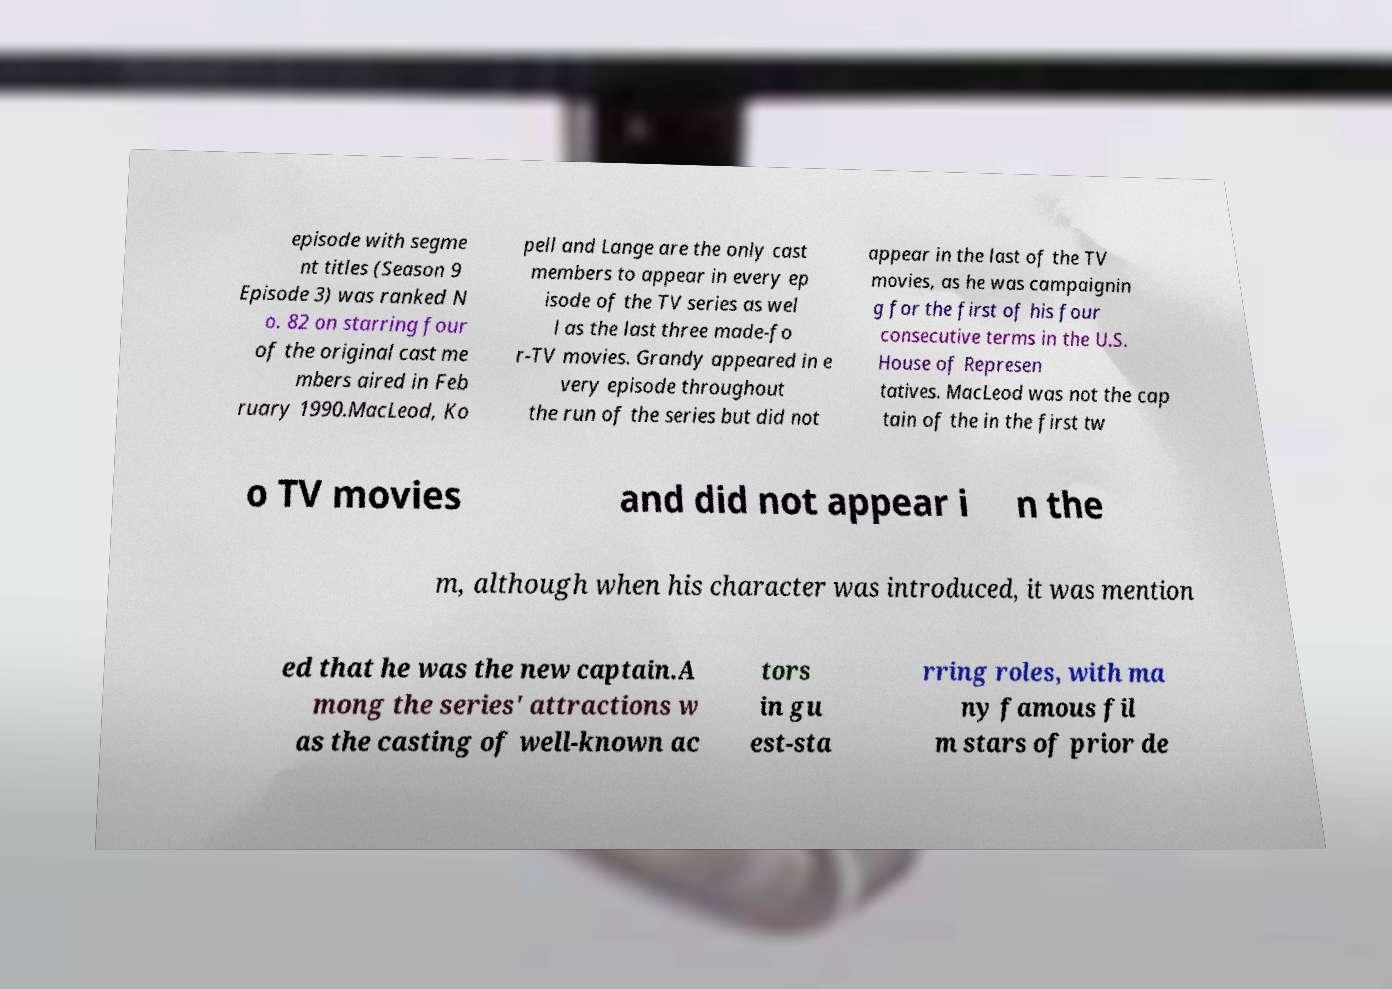Please identify and transcribe the text found in this image. episode with segme nt titles (Season 9 Episode 3) was ranked N o. 82 on starring four of the original cast me mbers aired in Feb ruary 1990.MacLeod, Ko pell and Lange are the only cast members to appear in every ep isode of the TV series as wel l as the last three made-fo r-TV movies. Grandy appeared in e very episode throughout the run of the series but did not appear in the last of the TV movies, as he was campaignin g for the first of his four consecutive terms in the U.S. House of Represen tatives. MacLeod was not the cap tain of the in the first tw o TV movies and did not appear i n the m, although when his character was introduced, it was mention ed that he was the new captain.A mong the series' attractions w as the casting of well-known ac tors in gu est-sta rring roles, with ma ny famous fil m stars of prior de 